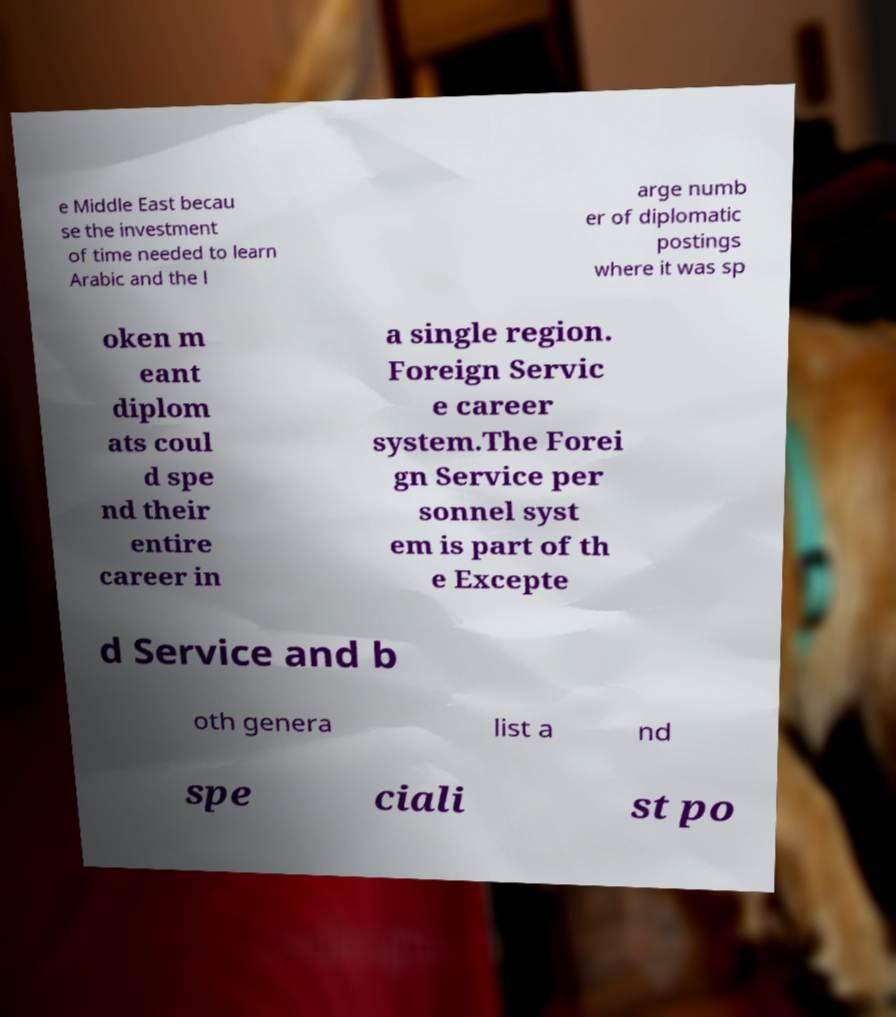I need the written content from this picture converted into text. Can you do that? e Middle East becau se the investment of time needed to learn Arabic and the l arge numb er of diplomatic postings where it was sp oken m eant diplom ats coul d spe nd their entire career in a single region. Foreign Servic e career system.The Forei gn Service per sonnel syst em is part of th e Excepte d Service and b oth genera list a nd spe ciali st po 